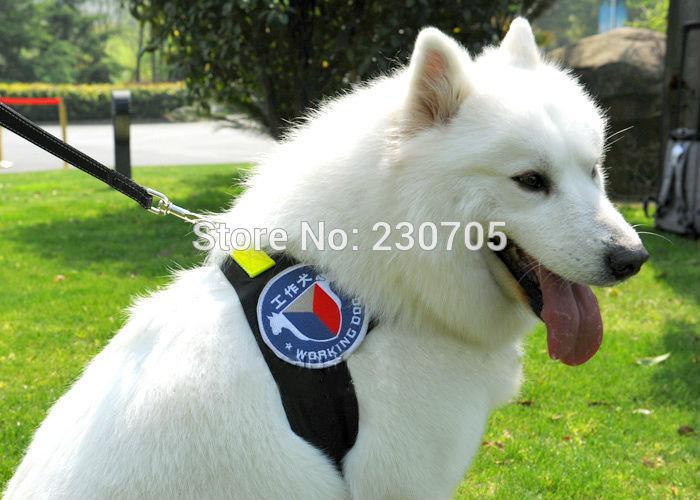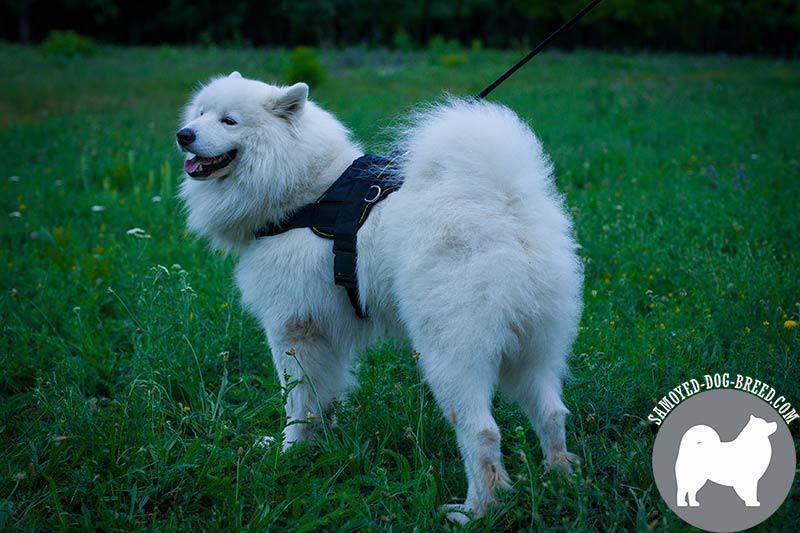The first image is the image on the left, the second image is the image on the right. Analyze the images presented: Is the assertion "One image shows a dog in a harness standing with head and body in profile, without a leash visible, and the other image shows a dog without a leash or harness." valid? Answer yes or no. No. The first image is the image on the left, the second image is the image on the right. Given the left and right images, does the statement "Each of two dogs at an outdoor grassy location has its mouth open with tongue showing and is wearing a leash." hold true? Answer yes or no. Yes. 